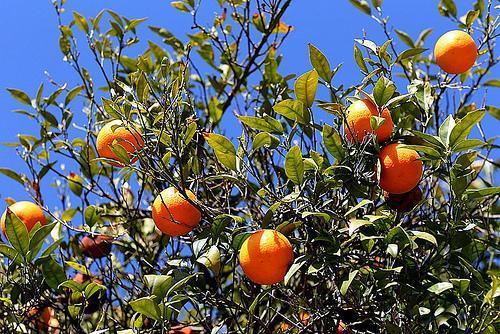How many oranges are clearly visible?
Give a very brief answer. 7. 